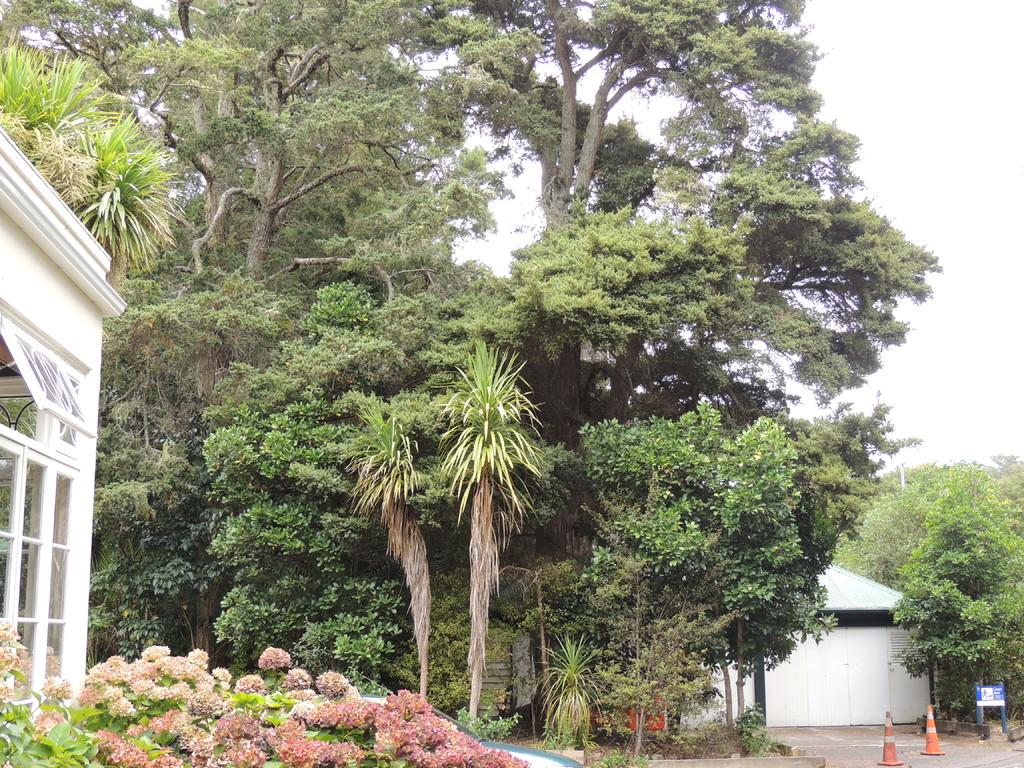What is the main feature of the image? The main feature of the image is the many trees that are planted. What else can be seen in the image? There are traffic cones, a walkway, a shelter, and glass objects visible in the image. What is the purpose of the traffic cones? The traffic cones are likely used to direct or control traffic in the area. What is the shelter used for? The shelter might provide shade or protection from the elements for people using the walkway. What is visible in the background of the image? The sky is visible in the background of the image. What type of sign can be seen on the trees in the image? There are no signs visible on the trees in the image. What kind of stamp is used to mark the glass objects in the image? There are no stamps visible on the glass objects in the image. 